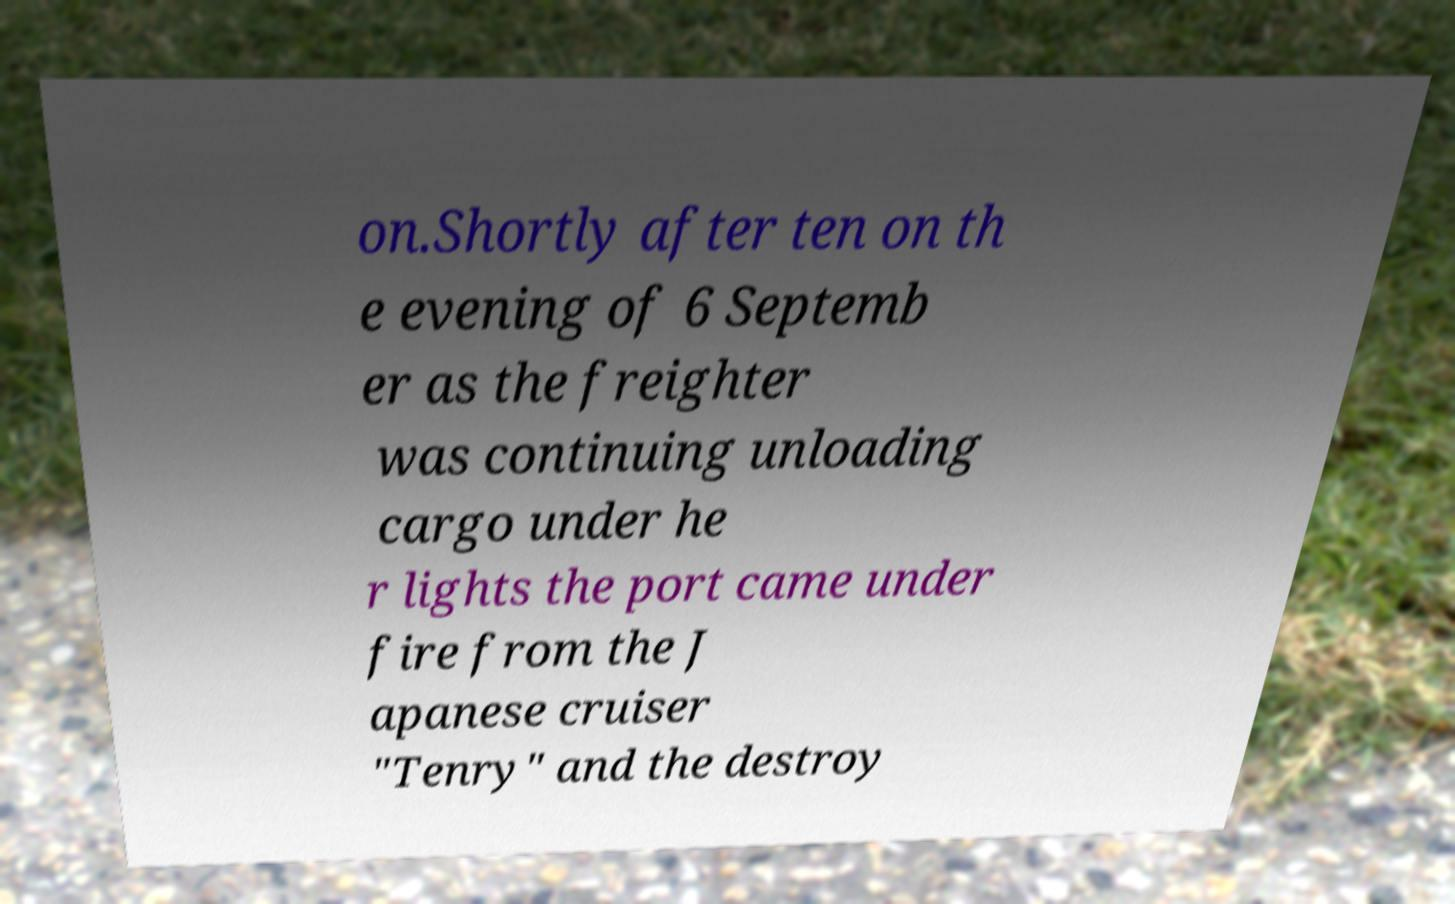Please identify and transcribe the text found in this image. on.Shortly after ten on th e evening of 6 Septemb er as the freighter was continuing unloading cargo under he r lights the port came under fire from the J apanese cruiser "Tenry" and the destroy 